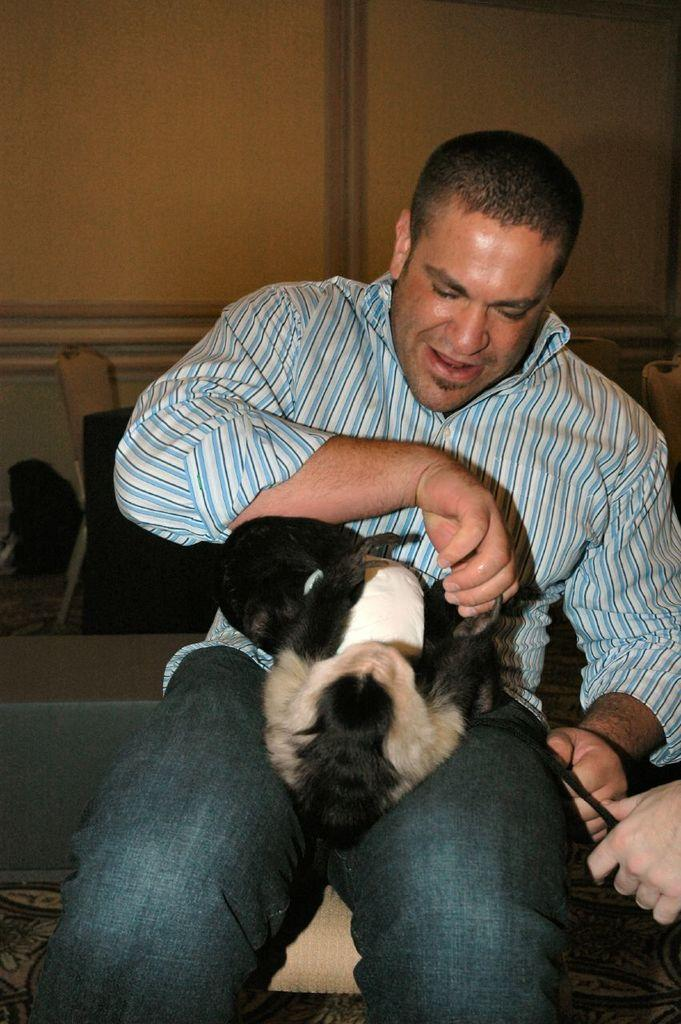What is the person in the image doing? The person is sitting on a chair in the image. What is the person holding in the image? The person is holding an animal in the image. Where is the animal located in relation to the person? The animal is on the right side of the image. What can be seen in the background of the image? There is a wall in the background of the image. What type of disease is the person suffering from in the image? There is no indication of any disease in the image; the person is simply sitting on a chair and holding an animal. 